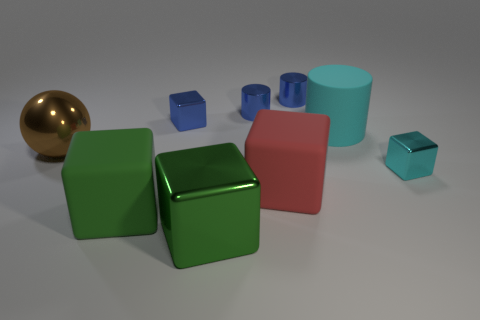Is there any other thing that has the same shape as the large brown thing?
Your response must be concise. No. What number of cubes are the same color as the big cylinder?
Ensure brevity in your answer.  1. There is a cyan object that is the same size as the brown shiny ball; what is its shape?
Keep it short and to the point. Cylinder. Is there a green rubber cube of the same size as the rubber cylinder?
Make the answer very short. Yes. There is a brown ball that is the same size as the red rubber thing; what is its material?
Offer a terse response. Metal. There is a rubber object that is left of the tiny block that is to the left of the cyan matte cylinder; how big is it?
Make the answer very short. Large. There is a rubber thing that is behind the brown sphere; does it have the same size as the large green metal thing?
Give a very brief answer. Yes. Is the number of big shiny cubes in front of the big rubber cylinder greater than the number of tiny cyan blocks in front of the cyan cube?
Your answer should be compact. Yes. The object that is behind the cyan metal thing and in front of the large cyan cylinder has what shape?
Offer a terse response. Sphere. There is a big matte object behind the large brown thing; what shape is it?
Provide a short and direct response. Cylinder. 